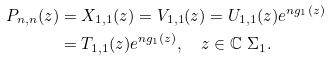Convert formula to latex. <formula><loc_0><loc_0><loc_500><loc_500>P _ { n , n } ( z ) & = X _ { 1 , 1 } ( z ) = V _ { 1 , 1 } ( z ) = U _ { 1 , 1 } ( z ) e ^ { n g _ { 1 } ( z ) } \\ & = T _ { 1 , 1 } ( z ) e ^ { n g _ { 1 } ( z ) } , \quad z \in \mathbb { C } \ \Sigma _ { 1 } .</formula> 